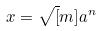Convert formula to latex. <formula><loc_0><loc_0><loc_500><loc_500>x = \sqrt { [ } m ] { a ^ { n } }</formula> 